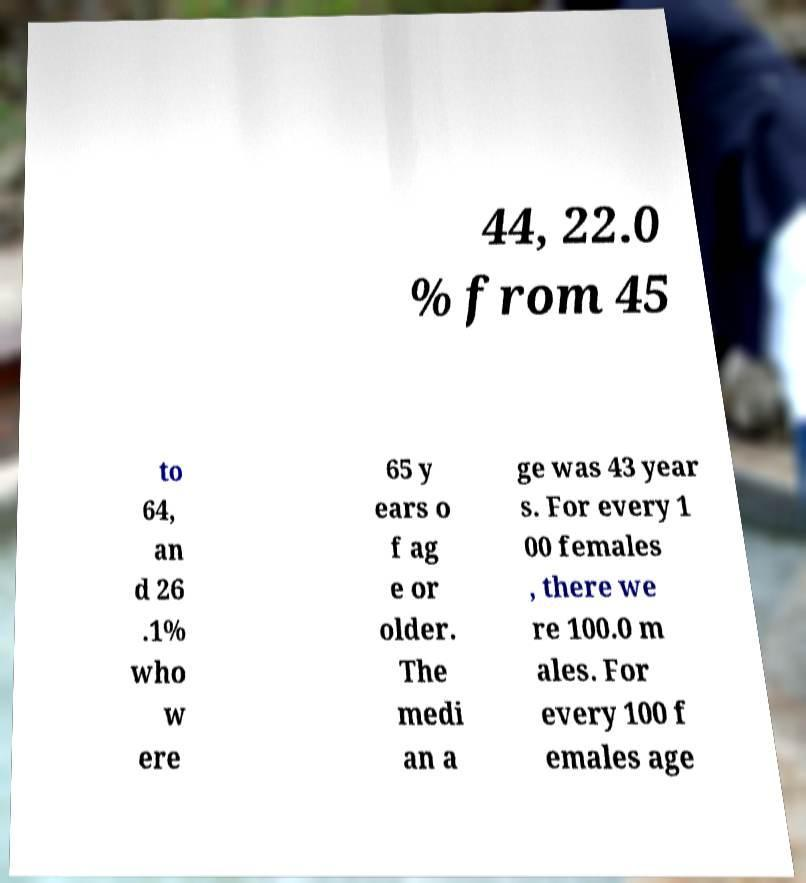Could you extract and type out the text from this image? 44, 22.0 % from 45 to 64, an d 26 .1% who w ere 65 y ears o f ag e or older. The medi an a ge was 43 year s. For every 1 00 females , there we re 100.0 m ales. For every 100 f emales age 